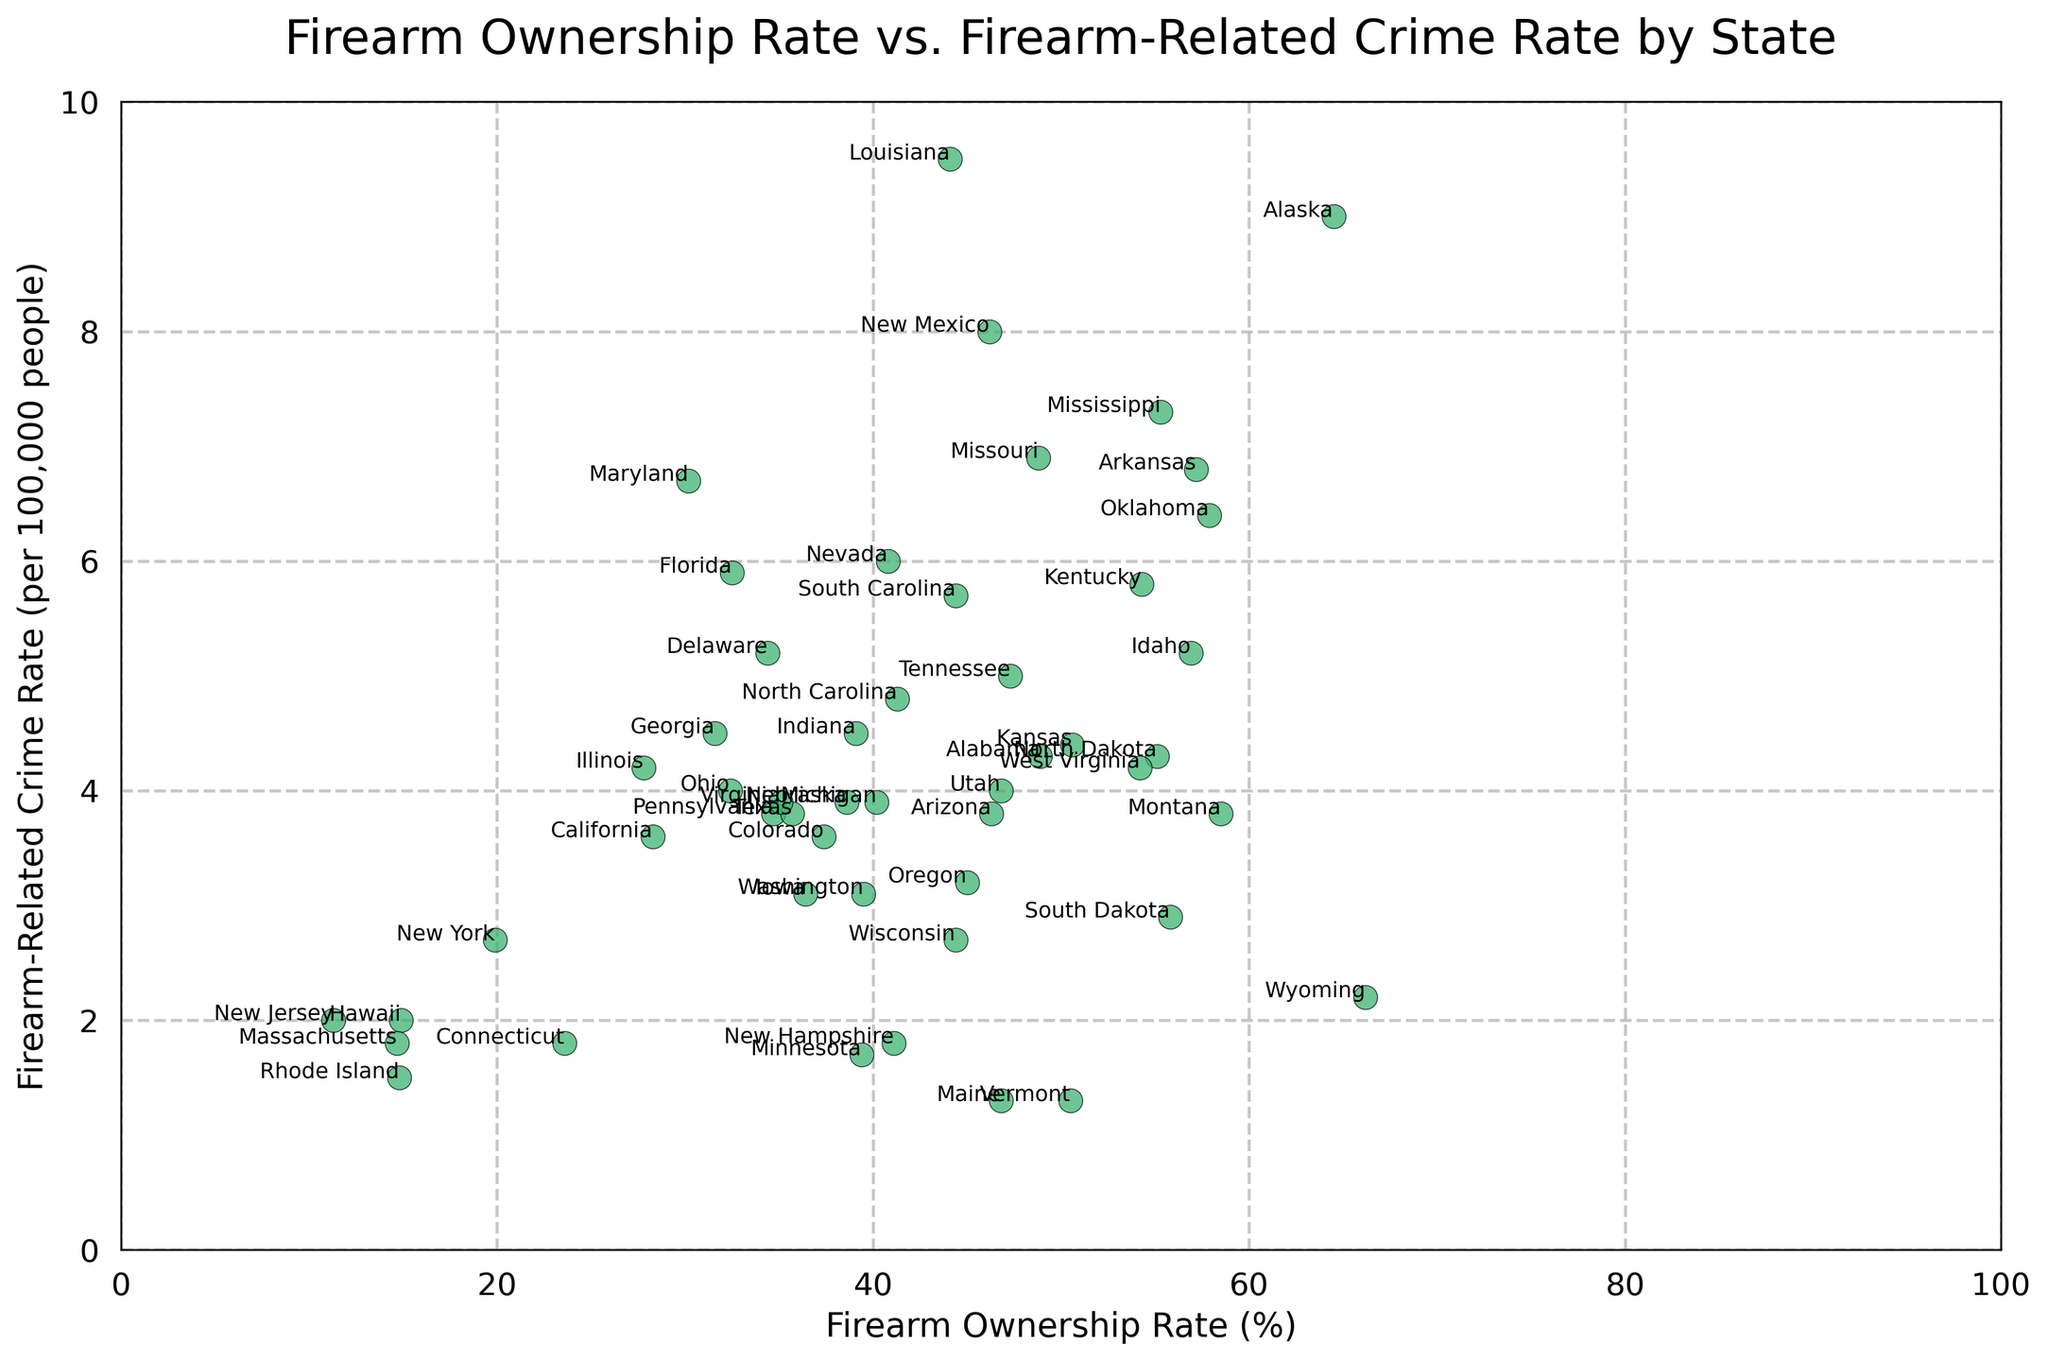How does the firearm ownership rate affect the firearm-related crime rate in states with ownership rates above 50%? First, identify the states with firearm ownership rates above 50%. These states include Alaska, Arkansas, Idaho, Kentucky, Mississippi, Missouri, Montana, North Dakota, Oklahoma, South Dakota, Vermont, and Wyoming. Observe the crime rates for these states and analyze if there is a clear trend or pattern.
Answer: Ownership rates above 50% show varying crime rates, with no clear trend Which state has the highest firearm-related crime rate, and what is its firearm ownership rate? Look for the state with the highest value on the y-axis (firearm-related crime rate). Louisiana stands out with the highest rate of 9.5. The corresponding x-axis value (ownership rate) is 44.1%.
Answer: Louisiana, 44.1% Which state has the lowest firearm-related crime rate, and what is its firearm ownership rate? Identify the state with the lowest value on the y-axis (firearm-related crime rate). Maine has the lowest rate at 1.3. The corresponding x-axis value (ownership rate) is 46.8%.
Answer: Maine, 46.8% Are there any states with similar firearm ownership rates but contrasting crime rates? Compare states with similar x-axis values (ownership rates) and check if their y-axis values (crime rates) are significantly different. For instance, Vermont and Arkansas have similar ownership rates (50.5% and 57.2%, respectively) but contrasting crime rates (1.3 and 6.8).
Answer: Vermont (1.3) and Arkansas (6.8) What is the average firearm ownership rate for states with a firearm-related crime rate below 2.5? First, identify states with crime rates below 2.5: Connecticut, Hawaii, Maine, Massachusetts, Minnesota, Rhode Island, Vermont, and Wyoming. Add their ownership rates: 23.6 + 14.9 + 46.8 + 14.7 + 39.4 + 14.8 + 50.5 + 66.2 = 271.9. Divide by the number of states (8) to find the average: 271.9 / 8 = 34.0.
Answer: 34.0% Which state has the highest firearm ownership rate and what is its firearm-related crime rate? Identify the state with the highest x-axis value which is Wyoming with an ownership rate of 66.2%. Look at its corresponding y-axis value which is the crime rate (2.2).
Answer: Wyoming, 2.2% How does the firearm-related crime rate in New York compare to that in Texas? Locate New York and Texas on the plot. New York has a crime rate of 2.7, while Texas has a rate of 3.8. Therefore, New York's crime rate is lower than Texas's.
Answer: Lower in New York Is there a clear correlation between firearm ownership rates and firearm-related crime rates? Observe the overall distribution of points in the scatter plot. Determine if higher ownership rates correspond to higher or lower crime rates. The points seem dispersed without forming a clear upward or downward trend, indicating no clear correlation.
Answer: No clear correlation 